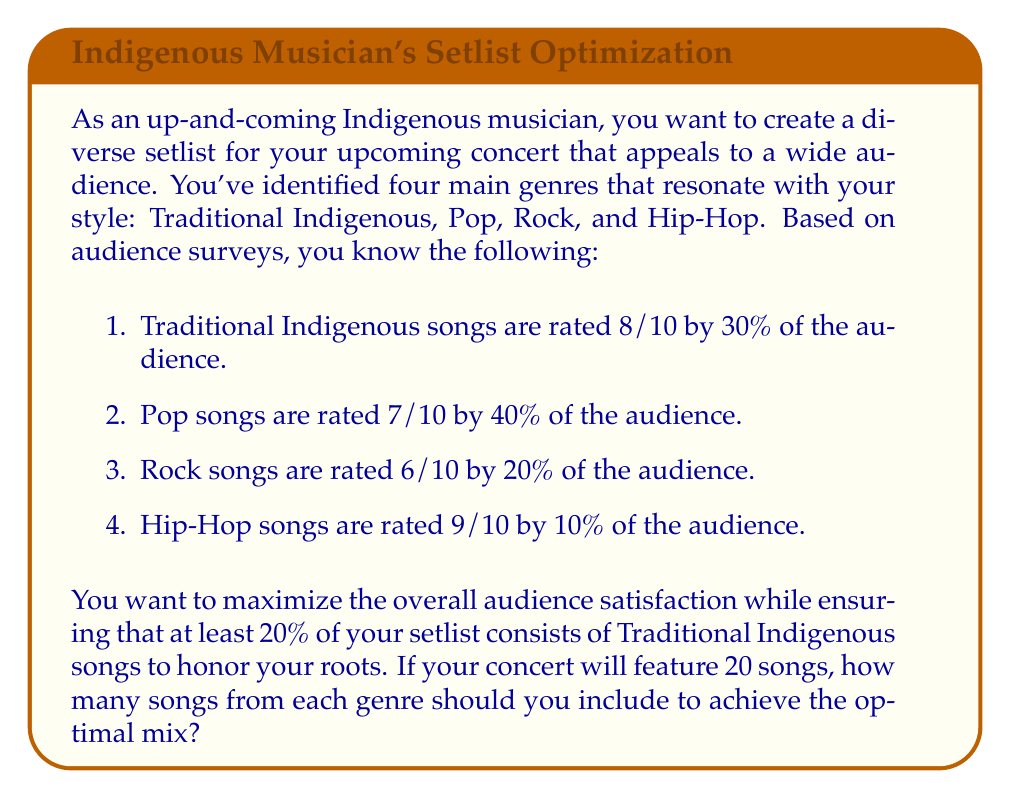Help me with this question. To solve this problem, we'll use linear programming. Let's define our variables:

$x_1$ = number of Traditional Indigenous songs
$x_2$ = number of Pop songs
$x_3$ = number of Rock songs
$x_4$ = number of Hip-Hop songs

Our objective function is to maximize audience satisfaction:

$$\text{Maximize } Z = 8(0.3x_1) + 7(0.4x_2) + 6(0.2x_3) + 9(0.1x_4)$$

Subject to the following constraints:

1. Total number of songs: $x_1 + x_2 + x_3 + x_4 = 20$
2. Minimum 20% Traditional Indigenous songs: $x_1 \geq 4$
3. Non-negativity: $x_1, x_2, x_3, x_4 \geq 0$

We can simplify the objective function:

$$\text{Maximize } Z = 2.4x_1 + 2.8x_2 + 1.2x_3 + 0.9x_4$$

To solve this, we can use the simplex method or a linear programming solver. However, we can also reason through it:

1. We must have at least 4 Traditional Indigenous songs.
2. Pop songs have the highest contribution to satisfaction per song (2.8), so we should maximize these after meeting the Traditional Indigenous requirement.
3. Hip-Hop has the next highest contribution (0.9), followed by Traditional Indigenous (2.4), and then Rock (1.2).

Therefore, the optimal solution would be:

1. Include the minimum 4 Traditional Indigenous songs.
2. Fill the remaining 16 slots with as many Pop songs as possible.

This gives us:

$x_1 = 4$ (Traditional Indigenous)
$x_2 = 16$ (Pop)
$x_3 = 0$ (Rock)
$x_4 = 0$ (Hip-Hop)

We can verify that this satisfies all constraints and maximizes the objective function.
Answer: The optimal mix of songs for the concert is:
4 Traditional Indigenous songs
16 Pop songs
0 Rock songs
0 Hip-Hop songs 